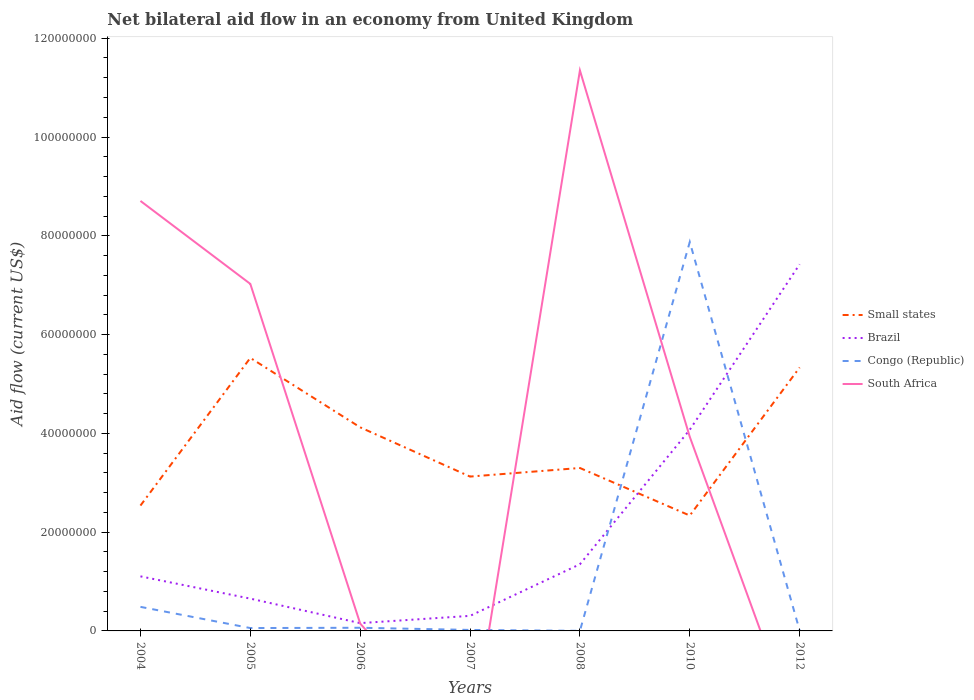Across all years, what is the maximum net bilateral aid flow in Brazil?
Keep it short and to the point. 1.58e+06. What is the total net bilateral aid flow in Small states in the graph?
Give a very brief answer. -5.87e+06. What is the difference between the highest and the second highest net bilateral aid flow in Small states?
Offer a terse response. 3.19e+07. What is the difference between the highest and the lowest net bilateral aid flow in Brazil?
Your response must be concise. 2. How many years are there in the graph?
Provide a short and direct response. 7. Are the values on the major ticks of Y-axis written in scientific E-notation?
Your answer should be very brief. No. Does the graph contain any zero values?
Keep it short and to the point. Yes. Where does the legend appear in the graph?
Provide a succinct answer. Center right. How are the legend labels stacked?
Offer a terse response. Vertical. What is the title of the graph?
Offer a very short reply. Net bilateral aid flow in an economy from United Kingdom. What is the label or title of the Y-axis?
Provide a short and direct response. Aid flow (current US$). What is the Aid flow (current US$) of Small states in 2004?
Offer a very short reply. 2.54e+07. What is the Aid flow (current US$) of Brazil in 2004?
Make the answer very short. 1.10e+07. What is the Aid flow (current US$) in Congo (Republic) in 2004?
Your answer should be compact. 4.87e+06. What is the Aid flow (current US$) of South Africa in 2004?
Keep it short and to the point. 8.71e+07. What is the Aid flow (current US$) in Small states in 2005?
Give a very brief answer. 5.53e+07. What is the Aid flow (current US$) in Brazil in 2005?
Give a very brief answer. 6.54e+06. What is the Aid flow (current US$) of Congo (Republic) in 2005?
Your answer should be very brief. 5.80e+05. What is the Aid flow (current US$) in South Africa in 2005?
Offer a terse response. 7.03e+07. What is the Aid flow (current US$) in Small states in 2006?
Ensure brevity in your answer.  4.12e+07. What is the Aid flow (current US$) of Brazil in 2006?
Offer a terse response. 1.58e+06. What is the Aid flow (current US$) in Congo (Republic) in 2006?
Make the answer very short. 6.40e+05. What is the Aid flow (current US$) of South Africa in 2006?
Ensure brevity in your answer.  1.49e+06. What is the Aid flow (current US$) of Small states in 2007?
Provide a short and direct response. 3.12e+07. What is the Aid flow (current US$) in Brazil in 2007?
Make the answer very short. 3.05e+06. What is the Aid flow (current US$) of South Africa in 2007?
Offer a very short reply. 0. What is the Aid flow (current US$) of Small states in 2008?
Offer a terse response. 3.30e+07. What is the Aid flow (current US$) of Brazil in 2008?
Provide a succinct answer. 1.35e+07. What is the Aid flow (current US$) of Congo (Republic) in 2008?
Give a very brief answer. 2.00e+04. What is the Aid flow (current US$) of South Africa in 2008?
Keep it short and to the point. 1.13e+08. What is the Aid flow (current US$) of Small states in 2010?
Give a very brief answer. 2.34e+07. What is the Aid flow (current US$) of Brazil in 2010?
Provide a succinct answer. 4.07e+07. What is the Aid flow (current US$) of Congo (Republic) in 2010?
Give a very brief answer. 7.88e+07. What is the Aid flow (current US$) of South Africa in 2010?
Keep it short and to the point. 3.93e+07. What is the Aid flow (current US$) of Small states in 2012?
Make the answer very short. 5.33e+07. What is the Aid flow (current US$) of Brazil in 2012?
Your answer should be compact. 7.42e+07. What is the Aid flow (current US$) in South Africa in 2012?
Provide a succinct answer. 0. Across all years, what is the maximum Aid flow (current US$) of Small states?
Your answer should be compact. 5.53e+07. Across all years, what is the maximum Aid flow (current US$) in Brazil?
Keep it short and to the point. 7.42e+07. Across all years, what is the maximum Aid flow (current US$) in Congo (Republic)?
Provide a succinct answer. 7.88e+07. Across all years, what is the maximum Aid flow (current US$) in South Africa?
Your answer should be very brief. 1.13e+08. Across all years, what is the minimum Aid flow (current US$) in Small states?
Your answer should be compact. 2.34e+07. Across all years, what is the minimum Aid flow (current US$) of Brazil?
Provide a succinct answer. 1.58e+06. Across all years, what is the minimum Aid flow (current US$) of South Africa?
Your answer should be compact. 0. What is the total Aid flow (current US$) in Small states in the graph?
Make the answer very short. 2.63e+08. What is the total Aid flow (current US$) of Brazil in the graph?
Make the answer very short. 1.51e+08. What is the total Aid flow (current US$) in Congo (Republic) in the graph?
Ensure brevity in your answer.  8.51e+07. What is the total Aid flow (current US$) of South Africa in the graph?
Keep it short and to the point. 3.12e+08. What is the difference between the Aid flow (current US$) of Small states in 2004 and that in 2005?
Keep it short and to the point. -2.99e+07. What is the difference between the Aid flow (current US$) in Brazil in 2004 and that in 2005?
Give a very brief answer. 4.51e+06. What is the difference between the Aid flow (current US$) in Congo (Republic) in 2004 and that in 2005?
Provide a succinct answer. 4.29e+06. What is the difference between the Aid flow (current US$) of South Africa in 2004 and that in 2005?
Make the answer very short. 1.68e+07. What is the difference between the Aid flow (current US$) of Small states in 2004 and that in 2006?
Keep it short and to the point. -1.58e+07. What is the difference between the Aid flow (current US$) in Brazil in 2004 and that in 2006?
Ensure brevity in your answer.  9.47e+06. What is the difference between the Aid flow (current US$) of Congo (Republic) in 2004 and that in 2006?
Your answer should be compact. 4.23e+06. What is the difference between the Aid flow (current US$) in South Africa in 2004 and that in 2006?
Your answer should be very brief. 8.56e+07. What is the difference between the Aid flow (current US$) in Small states in 2004 and that in 2007?
Your answer should be compact. -5.87e+06. What is the difference between the Aid flow (current US$) of Brazil in 2004 and that in 2007?
Make the answer very short. 8.00e+06. What is the difference between the Aid flow (current US$) of Congo (Republic) in 2004 and that in 2007?
Offer a very short reply. 4.67e+06. What is the difference between the Aid flow (current US$) in Small states in 2004 and that in 2008?
Provide a short and direct response. -7.61e+06. What is the difference between the Aid flow (current US$) of Brazil in 2004 and that in 2008?
Provide a short and direct response. -2.45e+06. What is the difference between the Aid flow (current US$) in Congo (Republic) in 2004 and that in 2008?
Your response must be concise. 4.85e+06. What is the difference between the Aid flow (current US$) in South Africa in 2004 and that in 2008?
Ensure brevity in your answer.  -2.64e+07. What is the difference between the Aid flow (current US$) in Small states in 2004 and that in 2010?
Provide a short and direct response. 2.02e+06. What is the difference between the Aid flow (current US$) of Brazil in 2004 and that in 2010?
Offer a terse response. -2.97e+07. What is the difference between the Aid flow (current US$) of Congo (Republic) in 2004 and that in 2010?
Provide a succinct answer. -7.39e+07. What is the difference between the Aid flow (current US$) in South Africa in 2004 and that in 2010?
Give a very brief answer. 4.78e+07. What is the difference between the Aid flow (current US$) in Small states in 2004 and that in 2012?
Provide a short and direct response. -2.80e+07. What is the difference between the Aid flow (current US$) in Brazil in 2004 and that in 2012?
Provide a short and direct response. -6.32e+07. What is the difference between the Aid flow (current US$) in Congo (Republic) in 2004 and that in 2012?
Give a very brief answer. 4.79e+06. What is the difference between the Aid flow (current US$) in Small states in 2005 and that in 2006?
Keep it short and to the point. 1.41e+07. What is the difference between the Aid flow (current US$) in Brazil in 2005 and that in 2006?
Your answer should be compact. 4.96e+06. What is the difference between the Aid flow (current US$) of Congo (Republic) in 2005 and that in 2006?
Your response must be concise. -6.00e+04. What is the difference between the Aid flow (current US$) in South Africa in 2005 and that in 2006?
Provide a short and direct response. 6.88e+07. What is the difference between the Aid flow (current US$) in Small states in 2005 and that in 2007?
Offer a very short reply. 2.40e+07. What is the difference between the Aid flow (current US$) of Brazil in 2005 and that in 2007?
Offer a terse response. 3.49e+06. What is the difference between the Aid flow (current US$) in Small states in 2005 and that in 2008?
Offer a terse response. 2.23e+07. What is the difference between the Aid flow (current US$) of Brazil in 2005 and that in 2008?
Ensure brevity in your answer.  -6.96e+06. What is the difference between the Aid flow (current US$) of Congo (Republic) in 2005 and that in 2008?
Your response must be concise. 5.60e+05. What is the difference between the Aid flow (current US$) in South Africa in 2005 and that in 2008?
Offer a very short reply. -4.32e+07. What is the difference between the Aid flow (current US$) of Small states in 2005 and that in 2010?
Your response must be concise. 3.19e+07. What is the difference between the Aid flow (current US$) in Brazil in 2005 and that in 2010?
Ensure brevity in your answer.  -3.42e+07. What is the difference between the Aid flow (current US$) of Congo (Republic) in 2005 and that in 2010?
Offer a terse response. -7.82e+07. What is the difference between the Aid flow (current US$) in South Africa in 2005 and that in 2010?
Offer a very short reply. 3.10e+07. What is the difference between the Aid flow (current US$) in Small states in 2005 and that in 2012?
Make the answer very short. 1.94e+06. What is the difference between the Aid flow (current US$) of Brazil in 2005 and that in 2012?
Give a very brief answer. -6.77e+07. What is the difference between the Aid flow (current US$) in Congo (Republic) in 2005 and that in 2012?
Your answer should be very brief. 5.00e+05. What is the difference between the Aid flow (current US$) in Small states in 2006 and that in 2007?
Ensure brevity in your answer.  9.97e+06. What is the difference between the Aid flow (current US$) in Brazil in 2006 and that in 2007?
Offer a very short reply. -1.47e+06. What is the difference between the Aid flow (current US$) in Small states in 2006 and that in 2008?
Ensure brevity in your answer.  8.23e+06. What is the difference between the Aid flow (current US$) of Brazil in 2006 and that in 2008?
Ensure brevity in your answer.  -1.19e+07. What is the difference between the Aid flow (current US$) in Congo (Republic) in 2006 and that in 2008?
Your answer should be compact. 6.20e+05. What is the difference between the Aid flow (current US$) of South Africa in 2006 and that in 2008?
Give a very brief answer. -1.12e+08. What is the difference between the Aid flow (current US$) of Small states in 2006 and that in 2010?
Make the answer very short. 1.79e+07. What is the difference between the Aid flow (current US$) in Brazil in 2006 and that in 2010?
Give a very brief answer. -3.92e+07. What is the difference between the Aid flow (current US$) in Congo (Republic) in 2006 and that in 2010?
Offer a very short reply. -7.81e+07. What is the difference between the Aid flow (current US$) in South Africa in 2006 and that in 2010?
Offer a terse response. -3.78e+07. What is the difference between the Aid flow (current US$) in Small states in 2006 and that in 2012?
Your answer should be very brief. -1.21e+07. What is the difference between the Aid flow (current US$) of Brazil in 2006 and that in 2012?
Give a very brief answer. -7.26e+07. What is the difference between the Aid flow (current US$) of Congo (Republic) in 2006 and that in 2012?
Keep it short and to the point. 5.60e+05. What is the difference between the Aid flow (current US$) of Small states in 2007 and that in 2008?
Provide a short and direct response. -1.74e+06. What is the difference between the Aid flow (current US$) in Brazil in 2007 and that in 2008?
Your response must be concise. -1.04e+07. What is the difference between the Aid flow (current US$) in Congo (Republic) in 2007 and that in 2008?
Your answer should be very brief. 1.80e+05. What is the difference between the Aid flow (current US$) in Small states in 2007 and that in 2010?
Your answer should be compact. 7.89e+06. What is the difference between the Aid flow (current US$) of Brazil in 2007 and that in 2010?
Your answer should be very brief. -3.77e+07. What is the difference between the Aid flow (current US$) of Congo (Republic) in 2007 and that in 2010?
Give a very brief answer. -7.86e+07. What is the difference between the Aid flow (current US$) of Small states in 2007 and that in 2012?
Provide a succinct answer. -2.21e+07. What is the difference between the Aid flow (current US$) in Brazil in 2007 and that in 2012?
Offer a very short reply. -7.12e+07. What is the difference between the Aid flow (current US$) of Small states in 2008 and that in 2010?
Give a very brief answer. 9.63e+06. What is the difference between the Aid flow (current US$) in Brazil in 2008 and that in 2010?
Offer a terse response. -2.72e+07. What is the difference between the Aid flow (current US$) of Congo (Republic) in 2008 and that in 2010?
Provide a short and direct response. -7.87e+07. What is the difference between the Aid flow (current US$) in South Africa in 2008 and that in 2010?
Offer a very short reply. 7.42e+07. What is the difference between the Aid flow (current US$) in Small states in 2008 and that in 2012?
Make the answer very short. -2.04e+07. What is the difference between the Aid flow (current US$) in Brazil in 2008 and that in 2012?
Offer a terse response. -6.07e+07. What is the difference between the Aid flow (current US$) in Congo (Republic) in 2008 and that in 2012?
Provide a short and direct response. -6.00e+04. What is the difference between the Aid flow (current US$) in Small states in 2010 and that in 2012?
Give a very brief answer. -3.00e+07. What is the difference between the Aid flow (current US$) in Brazil in 2010 and that in 2012?
Offer a very short reply. -3.35e+07. What is the difference between the Aid flow (current US$) of Congo (Republic) in 2010 and that in 2012?
Ensure brevity in your answer.  7.87e+07. What is the difference between the Aid flow (current US$) of Small states in 2004 and the Aid flow (current US$) of Brazil in 2005?
Offer a terse response. 1.88e+07. What is the difference between the Aid flow (current US$) in Small states in 2004 and the Aid flow (current US$) in Congo (Republic) in 2005?
Your response must be concise. 2.48e+07. What is the difference between the Aid flow (current US$) in Small states in 2004 and the Aid flow (current US$) in South Africa in 2005?
Make the answer very short. -4.49e+07. What is the difference between the Aid flow (current US$) in Brazil in 2004 and the Aid flow (current US$) in Congo (Republic) in 2005?
Provide a succinct answer. 1.05e+07. What is the difference between the Aid flow (current US$) in Brazil in 2004 and the Aid flow (current US$) in South Africa in 2005?
Give a very brief answer. -5.92e+07. What is the difference between the Aid flow (current US$) in Congo (Republic) in 2004 and the Aid flow (current US$) in South Africa in 2005?
Offer a very short reply. -6.54e+07. What is the difference between the Aid flow (current US$) in Small states in 2004 and the Aid flow (current US$) in Brazil in 2006?
Your answer should be compact. 2.38e+07. What is the difference between the Aid flow (current US$) of Small states in 2004 and the Aid flow (current US$) of Congo (Republic) in 2006?
Your response must be concise. 2.47e+07. What is the difference between the Aid flow (current US$) in Small states in 2004 and the Aid flow (current US$) in South Africa in 2006?
Provide a short and direct response. 2.39e+07. What is the difference between the Aid flow (current US$) in Brazil in 2004 and the Aid flow (current US$) in Congo (Republic) in 2006?
Give a very brief answer. 1.04e+07. What is the difference between the Aid flow (current US$) in Brazil in 2004 and the Aid flow (current US$) in South Africa in 2006?
Your answer should be compact. 9.56e+06. What is the difference between the Aid flow (current US$) of Congo (Republic) in 2004 and the Aid flow (current US$) of South Africa in 2006?
Your answer should be compact. 3.38e+06. What is the difference between the Aid flow (current US$) in Small states in 2004 and the Aid flow (current US$) in Brazil in 2007?
Provide a short and direct response. 2.23e+07. What is the difference between the Aid flow (current US$) of Small states in 2004 and the Aid flow (current US$) of Congo (Republic) in 2007?
Give a very brief answer. 2.52e+07. What is the difference between the Aid flow (current US$) in Brazil in 2004 and the Aid flow (current US$) in Congo (Republic) in 2007?
Keep it short and to the point. 1.08e+07. What is the difference between the Aid flow (current US$) of Small states in 2004 and the Aid flow (current US$) of Brazil in 2008?
Offer a very short reply. 1.19e+07. What is the difference between the Aid flow (current US$) in Small states in 2004 and the Aid flow (current US$) in Congo (Republic) in 2008?
Your answer should be compact. 2.54e+07. What is the difference between the Aid flow (current US$) in Small states in 2004 and the Aid flow (current US$) in South Africa in 2008?
Make the answer very short. -8.81e+07. What is the difference between the Aid flow (current US$) in Brazil in 2004 and the Aid flow (current US$) in Congo (Republic) in 2008?
Your answer should be compact. 1.10e+07. What is the difference between the Aid flow (current US$) in Brazil in 2004 and the Aid flow (current US$) in South Africa in 2008?
Provide a succinct answer. -1.02e+08. What is the difference between the Aid flow (current US$) in Congo (Republic) in 2004 and the Aid flow (current US$) in South Africa in 2008?
Your answer should be very brief. -1.09e+08. What is the difference between the Aid flow (current US$) of Small states in 2004 and the Aid flow (current US$) of Brazil in 2010?
Ensure brevity in your answer.  -1.54e+07. What is the difference between the Aid flow (current US$) of Small states in 2004 and the Aid flow (current US$) of Congo (Republic) in 2010?
Keep it short and to the point. -5.34e+07. What is the difference between the Aid flow (current US$) in Small states in 2004 and the Aid flow (current US$) in South Africa in 2010?
Your response must be concise. -1.39e+07. What is the difference between the Aid flow (current US$) of Brazil in 2004 and the Aid flow (current US$) of Congo (Republic) in 2010?
Make the answer very short. -6.77e+07. What is the difference between the Aid flow (current US$) of Brazil in 2004 and the Aid flow (current US$) of South Africa in 2010?
Give a very brief answer. -2.82e+07. What is the difference between the Aid flow (current US$) in Congo (Republic) in 2004 and the Aid flow (current US$) in South Africa in 2010?
Provide a succinct answer. -3.44e+07. What is the difference between the Aid flow (current US$) of Small states in 2004 and the Aid flow (current US$) of Brazil in 2012?
Offer a very short reply. -4.88e+07. What is the difference between the Aid flow (current US$) in Small states in 2004 and the Aid flow (current US$) in Congo (Republic) in 2012?
Offer a terse response. 2.53e+07. What is the difference between the Aid flow (current US$) in Brazil in 2004 and the Aid flow (current US$) in Congo (Republic) in 2012?
Offer a very short reply. 1.10e+07. What is the difference between the Aid flow (current US$) of Small states in 2005 and the Aid flow (current US$) of Brazil in 2006?
Your answer should be very brief. 5.37e+07. What is the difference between the Aid flow (current US$) in Small states in 2005 and the Aid flow (current US$) in Congo (Republic) in 2006?
Make the answer very short. 5.46e+07. What is the difference between the Aid flow (current US$) in Small states in 2005 and the Aid flow (current US$) in South Africa in 2006?
Make the answer very short. 5.38e+07. What is the difference between the Aid flow (current US$) in Brazil in 2005 and the Aid flow (current US$) in Congo (Republic) in 2006?
Offer a terse response. 5.90e+06. What is the difference between the Aid flow (current US$) in Brazil in 2005 and the Aid flow (current US$) in South Africa in 2006?
Your answer should be compact. 5.05e+06. What is the difference between the Aid flow (current US$) of Congo (Republic) in 2005 and the Aid flow (current US$) of South Africa in 2006?
Make the answer very short. -9.10e+05. What is the difference between the Aid flow (current US$) in Small states in 2005 and the Aid flow (current US$) in Brazil in 2007?
Ensure brevity in your answer.  5.22e+07. What is the difference between the Aid flow (current US$) in Small states in 2005 and the Aid flow (current US$) in Congo (Republic) in 2007?
Your response must be concise. 5.51e+07. What is the difference between the Aid flow (current US$) in Brazil in 2005 and the Aid flow (current US$) in Congo (Republic) in 2007?
Make the answer very short. 6.34e+06. What is the difference between the Aid flow (current US$) in Small states in 2005 and the Aid flow (current US$) in Brazil in 2008?
Ensure brevity in your answer.  4.18e+07. What is the difference between the Aid flow (current US$) in Small states in 2005 and the Aid flow (current US$) in Congo (Republic) in 2008?
Your answer should be compact. 5.53e+07. What is the difference between the Aid flow (current US$) of Small states in 2005 and the Aid flow (current US$) of South Africa in 2008?
Give a very brief answer. -5.82e+07. What is the difference between the Aid flow (current US$) of Brazil in 2005 and the Aid flow (current US$) of Congo (Republic) in 2008?
Keep it short and to the point. 6.52e+06. What is the difference between the Aid flow (current US$) of Brazil in 2005 and the Aid flow (current US$) of South Africa in 2008?
Your response must be concise. -1.07e+08. What is the difference between the Aid flow (current US$) in Congo (Republic) in 2005 and the Aid flow (current US$) in South Africa in 2008?
Give a very brief answer. -1.13e+08. What is the difference between the Aid flow (current US$) of Small states in 2005 and the Aid flow (current US$) of Brazil in 2010?
Your response must be concise. 1.46e+07. What is the difference between the Aid flow (current US$) of Small states in 2005 and the Aid flow (current US$) of Congo (Republic) in 2010?
Offer a terse response. -2.35e+07. What is the difference between the Aid flow (current US$) in Small states in 2005 and the Aid flow (current US$) in South Africa in 2010?
Provide a succinct answer. 1.60e+07. What is the difference between the Aid flow (current US$) of Brazil in 2005 and the Aid flow (current US$) of Congo (Republic) in 2010?
Give a very brief answer. -7.22e+07. What is the difference between the Aid flow (current US$) in Brazil in 2005 and the Aid flow (current US$) in South Africa in 2010?
Provide a succinct answer. -3.28e+07. What is the difference between the Aid flow (current US$) of Congo (Republic) in 2005 and the Aid flow (current US$) of South Africa in 2010?
Keep it short and to the point. -3.87e+07. What is the difference between the Aid flow (current US$) in Small states in 2005 and the Aid flow (current US$) in Brazil in 2012?
Ensure brevity in your answer.  -1.90e+07. What is the difference between the Aid flow (current US$) of Small states in 2005 and the Aid flow (current US$) of Congo (Republic) in 2012?
Keep it short and to the point. 5.52e+07. What is the difference between the Aid flow (current US$) in Brazil in 2005 and the Aid flow (current US$) in Congo (Republic) in 2012?
Your answer should be compact. 6.46e+06. What is the difference between the Aid flow (current US$) of Small states in 2006 and the Aid flow (current US$) of Brazil in 2007?
Offer a very short reply. 3.82e+07. What is the difference between the Aid flow (current US$) in Small states in 2006 and the Aid flow (current US$) in Congo (Republic) in 2007?
Provide a short and direct response. 4.10e+07. What is the difference between the Aid flow (current US$) of Brazil in 2006 and the Aid flow (current US$) of Congo (Republic) in 2007?
Your answer should be very brief. 1.38e+06. What is the difference between the Aid flow (current US$) in Small states in 2006 and the Aid flow (current US$) in Brazil in 2008?
Offer a terse response. 2.77e+07. What is the difference between the Aid flow (current US$) in Small states in 2006 and the Aid flow (current US$) in Congo (Republic) in 2008?
Your answer should be compact. 4.12e+07. What is the difference between the Aid flow (current US$) in Small states in 2006 and the Aid flow (current US$) in South Africa in 2008?
Offer a very short reply. -7.23e+07. What is the difference between the Aid flow (current US$) of Brazil in 2006 and the Aid flow (current US$) of Congo (Republic) in 2008?
Provide a short and direct response. 1.56e+06. What is the difference between the Aid flow (current US$) in Brazil in 2006 and the Aid flow (current US$) in South Africa in 2008?
Your answer should be compact. -1.12e+08. What is the difference between the Aid flow (current US$) in Congo (Republic) in 2006 and the Aid flow (current US$) in South Africa in 2008?
Offer a terse response. -1.13e+08. What is the difference between the Aid flow (current US$) of Small states in 2006 and the Aid flow (current US$) of Brazil in 2010?
Your answer should be very brief. 4.90e+05. What is the difference between the Aid flow (current US$) of Small states in 2006 and the Aid flow (current US$) of Congo (Republic) in 2010?
Your answer should be very brief. -3.75e+07. What is the difference between the Aid flow (current US$) of Small states in 2006 and the Aid flow (current US$) of South Africa in 2010?
Your response must be concise. 1.93e+06. What is the difference between the Aid flow (current US$) of Brazil in 2006 and the Aid flow (current US$) of Congo (Republic) in 2010?
Ensure brevity in your answer.  -7.72e+07. What is the difference between the Aid flow (current US$) in Brazil in 2006 and the Aid flow (current US$) in South Africa in 2010?
Give a very brief answer. -3.77e+07. What is the difference between the Aid flow (current US$) of Congo (Republic) in 2006 and the Aid flow (current US$) of South Africa in 2010?
Your answer should be very brief. -3.86e+07. What is the difference between the Aid flow (current US$) in Small states in 2006 and the Aid flow (current US$) in Brazil in 2012?
Your answer should be very brief. -3.30e+07. What is the difference between the Aid flow (current US$) of Small states in 2006 and the Aid flow (current US$) of Congo (Republic) in 2012?
Your answer should be very brief. 4.11e+07. What is the difference between the Aid flow (current US$) of Brazil in 2006 and the Aid flow (current US$) of Congo (Republic) in 2012?
Your response must be concise. 1.50e+06. What is the difference between the Aid flow (current US$) of Small states in 2007 and the Aid flow (current US$) of Brazil in 2008?
Your answer should be very brief. 1.78e+07. What is the difference between the Aid flow (current US$) in Small states in 2007 and the Aid flow (current US$) in Congo (Republic) in 2008?
Give a very brief answer. 3.12e+07. What is the difference between the Aid flow (current US$) of Small states in 2007 and the Aid flow (current US$) of South Africa in 2008?
Make the answer very short. -8.22e+07. What is the difference between the Aid flow (current US$) of Brazil in 2007 and the Aid flow (current US$) of Congo (Republic) in 2008?
Your response must be concise. 3.03e+06. What is the difference between the Aid flow (current US$) in Brazil in 2007 and the Aid flow (current US$) in South Africa in 2008?
Offer a very short reply. -1.10e+08. What is the difference between the Aid flow (current US$) in Congo (Republic) in 2007 and the Aid flow (current US$) in South Africa in 2008?
Offer a very short reply. -1.13e+08. What is the difference between the Aid flow (current US$) of Small states in 2007 and the Aid flow (current US$) of Brazil in 2010?
Make the answer very short. -9.48e+06. What is the difference between the Aid flow (current US$) in Small states in 2007 and the Aid flow (current US$) in Congo (Republic) in 2010?
Your answer should be compact. -4.75e+07. What is the difference between the Aid flow (current US$) of Small states in 2007 and the Aid flow (current US$) of South Africa in 2010?
Your answer should be compact. -8.04e+06. What is the difference between the Aid flow (current US$) of Brazil in 2007 and the Aid flow (current US$) of Congo (Republic) in 2010?
Your response must be concise. -7.57e+07. What is the difference between the Aid flow (current US$) in Brazil in 2007 and the Aid flow (current US$) in South Africa in 2010?
Provide a succinct answer. -3.62e+07. What is the difference between the Aid flow (current US$) of Congo (Republic) in 2007 and the Aid flow (current US$) of South Africa in 2010?
Give a very brief answer. -3.91e+07. What is the difference between the Aid flow (current US$) of Small states in 2007 and the Aid flow (current US$) of Brazil in 2012?
Make the answer very short. -4.30e+07. What is the difference between the Aid flow (current US$) of Small states in 2007 and the Aid flow (current US$) of Congo (Republic) in 2012?
Provide a succinct answer. 3.12e+07. What is the difference between the Aid flow (current US$) in Brazil in 2007 and the Aid flow (current US$) in Congo (Republic) in 2012?
Offer a very short reply. 2.97e+06. What is the difference between the Aid flow (current US$) in Small states in 2008 and the Aid flow (current US$) in Brazil in 2010?
Keep it short and to the point. -7.74e+06. What is the difference between the Aid flow (current US$) of Small states in 2008 and the Aid flow (current US$) of Congo (Republic) in 2010?
Provide a succinct answer. -4.58e+07. What is the difference between the Aid flow (current US$) of Small states in 2008 and the Aid flow (current US$) of South Africa in 2010?
Offer a very short reply. -6.30e+06. What is the difference between the Aid flow (current US$) of Brazil in 2008 and the Aid flow (current US$) of Congo (Republic) in 2010?
Offer a very short reply. -6.52e+07. What is the difference between the Aid flow (current US$) in Brazil in 2008 and the Aid flow (current US$) in South Africa in 2010?
Your answer should be compact. -2.58e+07. What is the difference between the Aid flow (current US$) in Congo (Republic) in 2008 and the Aid flow (current US$) in South Africa in 2010?
Keep it short and to the point. -3.93e+07. What is the difference between the Aid flow (current US$) in Small states in 2008 and the Aid flow (current US$) in Brazil in 2012?
Your answer should be very brief. -4.12e+07. What is the difference between the Aid flow (current US$) in Small states in 2008 and the Aid flow (current US$) in Congo (Republic) in 2012?
Your response must be concise. 3.29e+07. What is the difference between the Aid flow (current US$) in Brazil in 2008 and the Aid flow (current US$) in Congo (Republic) in 2012?
Your answer should be very brief. 1.34e+07. What is the difference between the Aid flow (current US$) of Small states in 2010 and the Aid flow (current US$) of Brazil in 2012?
Offer a terse response. -5.09e+07. What is the difference between the Aid flow (current US$) in Small states in 2010 and the Aid flow (current US$) in Congo (Republic) in 2012?
Ensure brevity in your answer.  2.33e+07. What is the difference between the Aid flow (current US$) of Brazil in 2010 and the Aid flow (current US$) of Congo (Republic) in 2012?
Your response must be concise. 4.06e+07. What is the average Aid flow (current US$) in Small states per year?
Ensure brevity in your answer.  3.75e+07. What is the average Aid flow (current US$) of Brazil per year?
Give a very brief answer. 2.15e+07. What is the average Aid flow (current US$) of Congo (Republic) per year?
Your answer should be compact. 1.22e+07. What is the average Aid flow (current US$) in South Africa per year?
Offer a very short reply. 4.45e+07. In the year 2004, what is the difference between the Aid flow (current US$) of Small states and Aid flow (current US$) of Brazil?
Your answer should be compact. 1.43e+07. In the year 2004, what is the difference between the Aid flow (current US$) in Small states and Aid flow (current US$) in Congo (Republic)?
Your answer should be compact. 2.05e+07. In the year 2004, what is the difference between the Aid flow (current US$) of Small states and Aid flow (current US$) of South Africa?
Your answer should be compact. -6.17e+07. In the year 2004, what is the difference between the Aid flow (current US$) in Brazil and Aid flow (current US$) in Congo (Republic)?
Your response must be concise. 6.18e+06. In the year 2004, what is the difference between the Aid flow (current US$) in Brazil and Aid flow (current US$) in South Africa?
Provide a succinct answer. -7.60e+07. In the year 2004, what is the difference between the Aid flow (current US$) in Congo (Republic) and Aid flow (current US$) in South Africa?
Offer a terse response. -8.22e+07. In the year 2005, what is the difference between the Aid flow (current US$) in Small states and Aid flow (current US$) in Brazil?
Your answer should be very brief. 4.87e+07. In the year 2005, what is the difference between the Aid flow (current US$) of Small states and Aid flow (current US$) of Congo (Republic)?
Provide a succinct answer. 5.47e+07. In the year 2005, what is the difference between the Aid flow (current US$) in Small states and Aid flow (current US$) in South Africa?
Keep it short and to the point. -1.50e+07. In the year 2005, what is the difference between the Aid flow (current US$) in Brazil and Aid flow (current US$) in Congo (Republic)?
Offer a very short reply. 5.96e+06. In the year 2005, what is the difference between the Aid flow (current US$) of Brazil and Aid flow (current US$) of South Africa?
Your response must be concise. -6.37e+07. In the year 2005, what is the difference between the Aid flow (current US$) in Congo (Republic) and Aid flow (current US$) in South Africa?
Ensure brevity in your answer.  -6.97e+07. In the year 2006, what is the difference between the Aid flow (current US$) in Small states and Aid flow (current US$) in Brazil?
Your answer should be very brief. 3.96e+07. In the year 2006, what is the difference between the Aid flow (current US$) in Small states and Aid flow (current US$) in Congo (Republic)?
Offer a very short reply. 4.06e+07. In the year 2006, what is the difference between the Aid flow (current US$) of Small states and Aid flow (current US$) of South Africa?
Give a very brief answer. 3.97e+07. In the year 2006, what is the difference between the Aid flow (current US$) of Brazil and Aid flow (current US$) of Congo (Republic)?
Ensure brevity in your answer.  9.40e+05. In the year 2006, what is the difference between the Aid flow (current US$) in Brazil and Aid flow (current US$) in South Africa?
Ensure brevity in your answer.  9.00e+04. In the year 2006, what is the difference between the Aid flow (current US$) of Congo (Republic) and Aid flow (current US$) of South Africa?
Give a very brief answer. -8.50e+05. In the year 2007, what is the difference between the Aid flow (current US$) of Small states and Aid flow (current US$) of Brazil?
Keep it short and to the point. 2.82e+07. In the year 2007, what is the difference between the Aid flow (current US$) of Small states and Aid flow (current US$) of Congo (Republic)?
Your answer should be very brief. 3.10e+07. In the year 2007, what is the difference between the Aid flow (current US$) of Brazil and Aid flow (current US$) of Congo (Republic)?
Offer a terse response. 2.85e+06. In the year 2008, what is the difference between the Aid flow (current US$) in Small states and Aid flow (current US$) in Brazil?
Your answer should be compact. 1.95e+07. In the year 2008, what is the difference between the Aid flow (current US$) of Small states and Aid flow (current US$) of Congo (Republic)?
Make the answer very short. 3.30e+07. In the year 2008, what is the difference between the Aid flow (current US$) of Small states and Aid flow (current US$) of South Africa?
Give a very brief answer. -8.05e+07. In the year 2008, what is the difference between the Aid flow (current US$) in Brazil and Aid flow (current US$) in Congo (Republic)?
Give a very brief answer. 1.35e+07. In the year 2008, what is the difference between the Aid flow (current US$) of Brazil and Aid flow (current US$) of South Africa?
Provide a short and direct response. -1.00e+08. In the year 2008, what is the difference between the Aid flow (current US$) in Congo (Republic) and Aid flow (current US$) in South Africa?
Your answer should be compact. -1.13e+08. In the year 2010, what is the difference between the Aid flow (current US$) of Small states and Aid flow (current US$) of Brazil?
Provide a succinct answer. -1.74e+07. In the year 2010, what is the difference between the Aid flow (current US$) in Small states and Aid flow (current US$) in Congo (Republic)?
Give a very brief answer. -5.54e+07. In the year 2010, what is the difference between the Aid flow (current US$) in Small states and Aid flow (current US$) in South Africa?
Ensure brevity in your answer.  -1.59e+07. In the year 2010, what is the difference between the Aid flow (current US$) in Brazil and Aid flow (current US$) in Congo (Republic)?
Your response must be concise. -3.80e+07. In the year 2010, what is the difference between the Aid flow (current US$) of Brazil and Aid flow (current US$) of South Africa?
Offer a very short reply. 1.44e+06. In the year 2010, what is the difference between the Aid flow (current US$) in Congo (Republic) and Aid flow (current US$) in South Africa?
Offer a very short reply. 3.95e+07. In the year 2012, what is the difference between the Aid flow (current US$) of Small states and Aid flow (current US$) of Brazil?
Make the answer very short. -2.09e+07. In the year 2012, what is the difference between the Aid flow (current US$) of Small states and Aid flow (current US$) of Congo (Republic)?
Provide a succinct answer. 5.33e+07. In the year 2012, what is the difference between the Aid flow (current US$) in Brazil and Aid flow (current US$) in Congo (Republic)?
Give a very brief answer. 7.42e+07. What is the ratio of the Aid flow (current US$) in Small states in 2004 to that in 2005?
Make the answer very short. 0.46. What is the ratio of the Aid flow (current US$) of Brazil in 2004 to that in 2005?
Provide a succinct answer. 1.69. What is the ratio of the Aid flow (current US$) in Congo (Republic) in 2004 to that in 2005?
Your response must be concise. 8.4. What is the ratio of the Aid flow (current US$) of South Africa in 2004 to that in 2005?
Give a very brief answer. 1.24. What is the ratio of the Aid flow (current US$) of Small states in 2004 to that in 2006?
Make the answer very short. 0.62. What is the ratio of the Aid flow (current US$) in Brazil in 2004 to that in 2006?
Offer a very short reply. 6.99. What is the ratio of the Aid flow (current US$) of Congo (Republic) in 2004 to that in 2006?
Provide a short and direct response. 7.61. What is the ratio of the Aid flow (current US$) of South Africa in 2004 to that in 2006?
Your answer should be very brief. 58.43. What is the ratio of the Aid flow (current US$) in Small states in 2004 to that in 2007?
Give a very brief answer. 0.81. What is the ratio of the Aid flow (current US$) of Brazil in 2004 to that in 2007?
Make the answer very short. 3.62. What is the ratio of the Aid flow (current US$) of Congo (Republic) in 2004 to that in 2007?
Your response must be concise. 24.35. What is the ratio of the Aid flow (current US$) of Small states in 2004 to that in 2008?
Provide a short and direct response. 0.77. What is the ratio of the Aid flow (current US$) of Brazil in 2004 to that in 2008?
Make the answer very short. 0.82. What is the ratio of the Aid flow (current US$) of Congo (Republic) in 2004 to that in 2008?
Offer a terse response. 243.5. What is the ratio of the Aid flow (current US$) of South Africa in 2004 to that in 2008?
Your answer should be very brief. 0.77. What is the ratio of the Aid flow (current US$) of Small states in 2004 to that in 2010?
Provide a succinct answer. 1.09. What is the ratio of the Aid flow (current US$) of Brazil in 2004 to that in 2010?
Ensure brevity in your answer.  0.27. What is the ratio of the Aid flow (current US$) of Congo (Republic) in 2004 to that in 2010?
Provide a succinct answer. 0.06. What is the ratio of the Aid flow (current US$) in South Africa in 2004 to that in 2010?
Give a very brief answer. 2.22. What is the ratio of the Aid flow (current US$) in Small states in 2004 to that in 2012?
Offer a terse response. 0.48. What is the ratio of the Aid flow (current US$) of Brazil in 2004 to that in 2012?
Keep it short and to the point. 0.15. What is the ratio of the Aid flow (current US$) in Congo (Republic) in 2004 to that in 2012?
Ensure brevity in your answer.  60.88. What is the ratio of the Aid flow (current US$) in Small states in 2005 to that in 2006?
Your answer should be very brief. 1.34. What is the ratio of the Aid flow (current US$) in Brazil in 2005 to that in 2006?
Offer a terse response. 4.14. What is the ratio of the Aid flow (current US$) in Congo (Republic) in 2005 to that in 2006?
Ensure brevity in your answer.  0.91. What is the ratio of the Aid flow (current US$) in South Africa in 2005 to that in 2006?
Offer a terse response. 47.15. What is the ratio of the Aid flow (current US$) in Small states in 2005 to that in 2007?
Offer a very short reply. 1.77. What is the ratio of the Aid flow (current US$) in Brazil in 2005 to that in 2007?
Offer a very short reply. 2.14. What is the ratio of the Aid flow (current US$) of Congo (Republic) in 2005 to that in 2007?
Provide a short and direct response. 2.9. What is the ratio of the Aid flow (current US$) of Small states in 2005 to that in 2008?
Provide a short and direct response. 1.68. What is the ratio of the Aid flow (current US$) in Brazil in 2005 to that in 2008?
Provide a short and direct response. 0.48. What is the ratio of the Aid flow (current US$) of South Africa in 2005 to that in 2008?
Keep it short and to the point. 0.62. What is the ratio of the Aid flow (current US$) of Small states in 2005 to that in 2010?
Your response must be concise. 2.37. What is the ratio of the Aid flow (current US$) in Brazil in 2005 to that in 2010?
Your response must be concise. 0.16. What is the ratio of the Aid flow (current US$) in Congo (Republic) in 2005 to that in 2010?
Keep it short and to the point. 0.01. What is the ratio of the Aid flow (current US$) in South Africa in 2005 to that in 2010?
Ensure brevity in your answer.  1.79. What is the ratio of the Aid flow (current US$) in Small states in 2005 to that in 2012?
Provide a short and direct response. 1.04. What is the ratio of the Aid flow (current US$) in Brazil in 2005 to that in 2012?
Keep it short and to the point. 0.09. What is the ratio of the Aid flow (current US$) of Congo (Republic) in 2005 to that in 2012?
Your answer should be compact. 7.25. What is the ratio of the Aid flow (current US$) of Small states in 2006 to that in 2007?
Offer a terse response. 1.32. What is the ratio of the Aid flow (current US$) of Brazil in 2006 to that in 2007?
Offer a terse response. 0.52. What is the ratio of the Aid flow (current US$) of Congo (Republic) in 2006 to that in 2007?
Provide a short and direct response. 3.2. What is the ratio of the Aid flow (current US$) of Small states in 2006 to that in 2008?
Your answer should be compact. 1.25. What is the ratio of the Aid flow (current US$) of Brazil in 2006 to that in 2008?
Your answer should be compact. 0.12. What is the ratio of the Aid flow (current US$) of Congo (Republic) in 2006 to that in 2008?
Ensure brevity in your answer.  32. What is the ratio of the Aid flow (current US$) of South Africa in 2006 to that in 2008?
Provide a short and direct response. 0.01. What is the ratio of the Aid flow (current US$) in Small states in 2006 to that in 2010?
Your response must be concise. 1.76. What is the ratio of the Aid flow (current US$) in Brazil in 2006 to that in 2010?
Give a very brief answer. 0.04. What is the ratio of the Aid flow (current US$) of Congo (Republic) in 2006 to that in 2010?
Offer a very short reply. 0.01. What is the ratio of the Aid flow (current US$) in South Africa in 2006 to that in 2010?
Offer a terse response. 0.04. What is the ratio of the Aid flow (current US$) in Small states in 2006 to that in 2012?
Give a very brief answer. 0.77. What is the ratio of the Aid flow (current US$) of Brazil in 2006 to that in 2012?
Offer a terse response. 0.02. What is the ratio of the Aid flow (current US$) of Small states in 2007 to that in 2008?
Your answer should be compact. 0.95. What is the ratio of the Aid flow (current US$) of Brazil in 2007 to that in 2008?
Provide a succinct answer. 0.23. What is the ratio of the Aid flow (current US$) in Small states in 2007 to that in 2010?
Keep it short and to the point. 1.34. What is the ratio of the Aid flow (current US$) of Brazil in 2007 to that in 2010?
Offer a terse response. 0.07. What is the ratio of the Aid flow (current US$) of Congo (Republic) in 2007 to that in 2010?
Your answer should be compact. 0. What is the ratio of the Aid flow (current US$) of Small states in 2007 to that in 2012?
Offer a very short reply. 0.59. What is the ratio of the Aid flow (current US$) in Brazil in 2007 to that in 2012?
Your answer should be very brief. 0.04. What is the ratio of the Aid flow (current US$) of Congo (Republic) in 2007 to that in 2012?
Give a very brief answer. 2.5. What is the ratio of the Aid flow (current US$) in Small states in 2008 to that in 2010?
Provide a short and direct response. 1.41. What is the ratio of the Aid flow (current US$) in Brazil in 2008 to that in 2010?
Your answer should be very brief. 0.33. What is the ratio of the Aid flow (current US$) of Congo (Republic) in 2008 to that in 2010?
Give a very brief answer. 0. What is the ratio of the Aid flow (current US$) in South Africa in 2008 to that in 2010?
Keep it short and to the point. 2.89. What is the ratio of the Aid flow (current US$) in Small states in 2008 to that in 2012?
Ensure brevity in your answer.  0.62. What is the ratio of the Aid flow (current US$) in Brazil in 2008 to that in 2012?
Your answer should be compact. 0.18. What is the ratio of the Aid flow (current US$) in Small states in 2010 to that in 2012?
Your answer should be compact. 0.44. What is the ratio of the Aid flow (current US$) of Brazil in 2010 to that in 2012?
Your answer should be compact. 0.55. What is the ratio of the Aid flow (current US$) of Congo (Republic) in 2010 to that in 2012?
Offer a very short reply. 984.38. What is the difference between the highest and the second highest Aid flow (current US$) of Small states?
Keep it short and to the point. 1.94e+06. What is the difference between the highest and the second highest Aid flow (current US$) of Brazil?
Make the answer very short. 3.35e+07. What is the difference between the highest and the second highest Aid flow (current US$) of Congo (Republic)?
Offer a terse response. 7.39e+07. What is the difference between the highest and the second highest Aid flow (current US$) in South Africa?
Keep it short and to the point. 2.64e+07. What is the difference between the highest and the lowest Aid flow (current US$) in Small states?
Your answer should be very brief. 3.19e+07. What is the difference between the highest and the lowest Aid flow (current US$) of Brazil?
Your answer should be compact. 7.26e+07. What is the difference between the highest and the lowest Aid flow (current US$) in Congo (Republic)?
Your response must be concise. 7.87e+07. What is the difference between the highest and the lowest Aid flow (current US$) of South Africa?
Your answer should be very brief. 1.13e+08. 